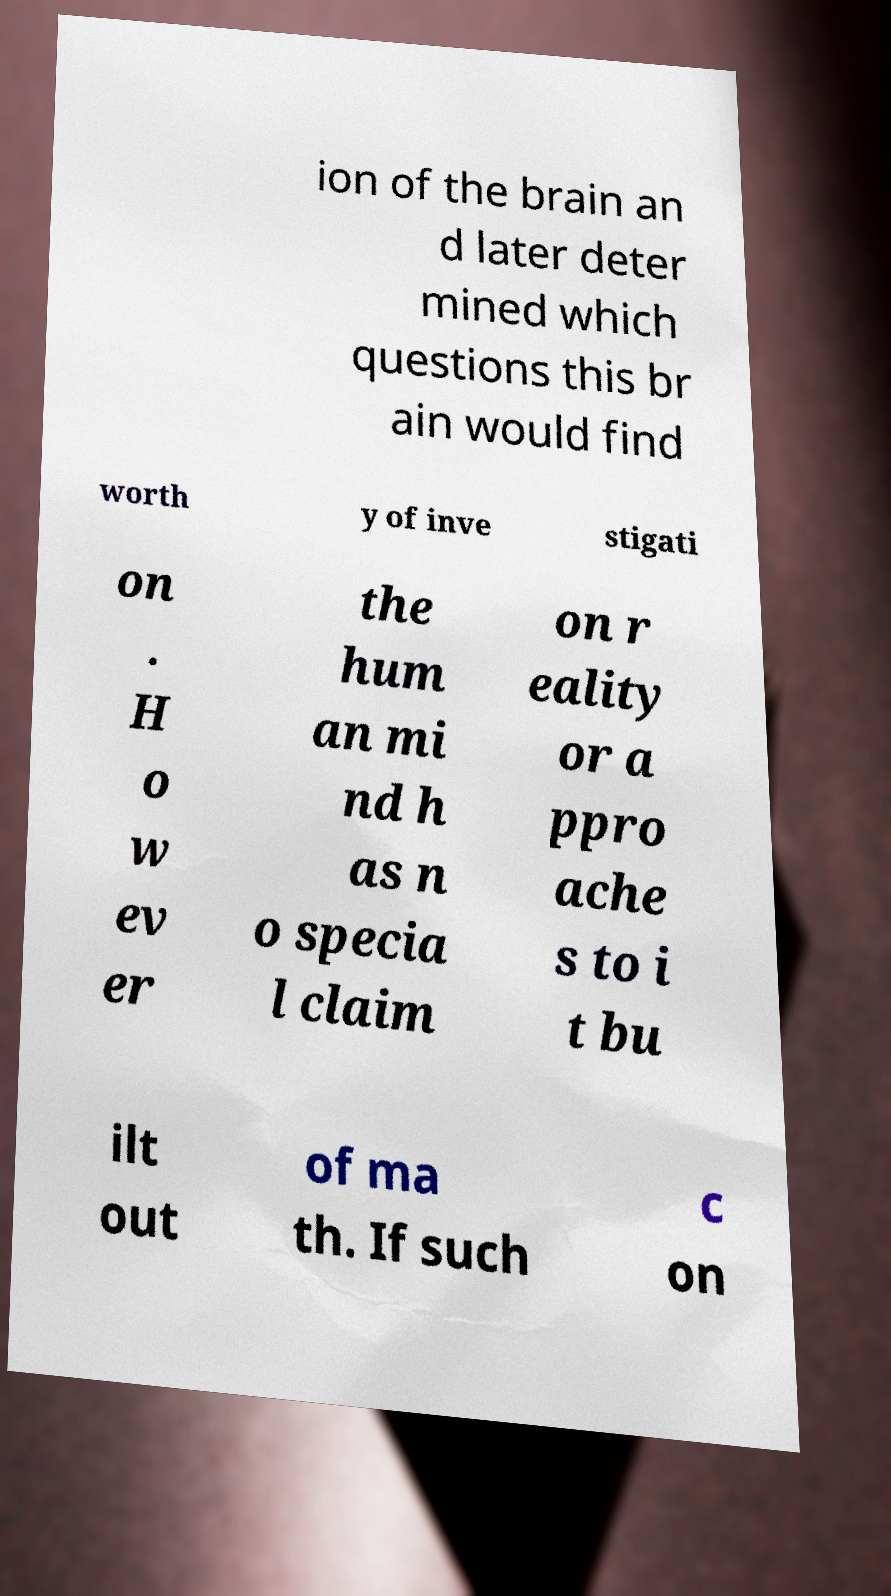Please identify and transcribe the text found in this image. ion of the brain an d later deter mined which questions this br ain would find worth y of inve stigati on . H o w ev er the hum an mi nd h as n o specia l claim on r eality or a ppro ache s to i t bu ilt out of ma th. If such c on 